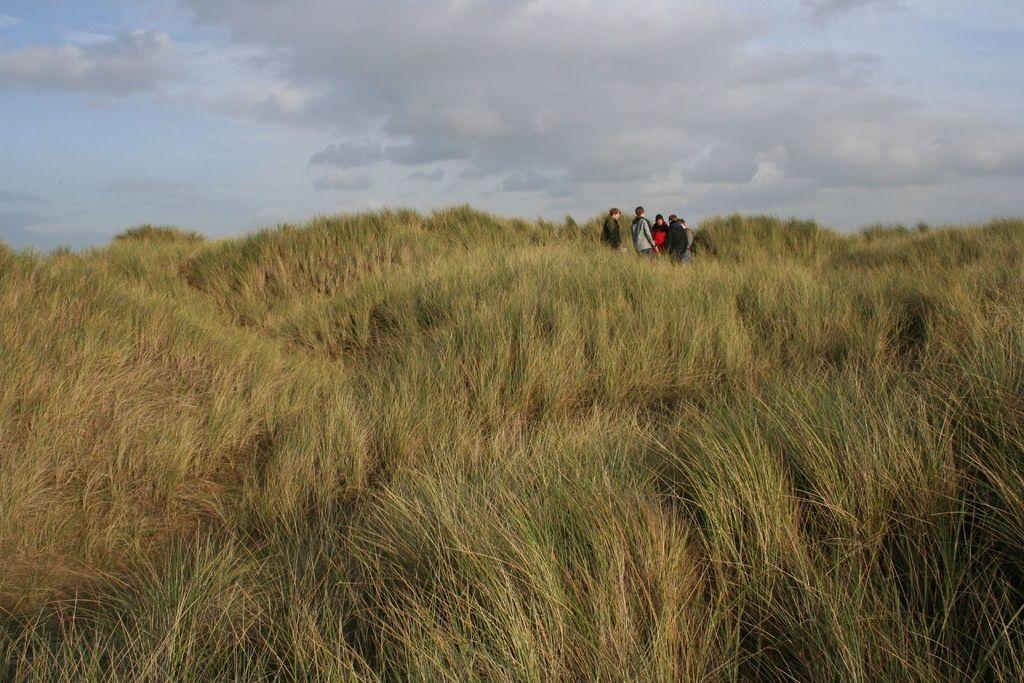In one or two sentences, can you explain what this image depicts? There are grass and there are few persons standing in between them and the sky is a bit cloudy. 